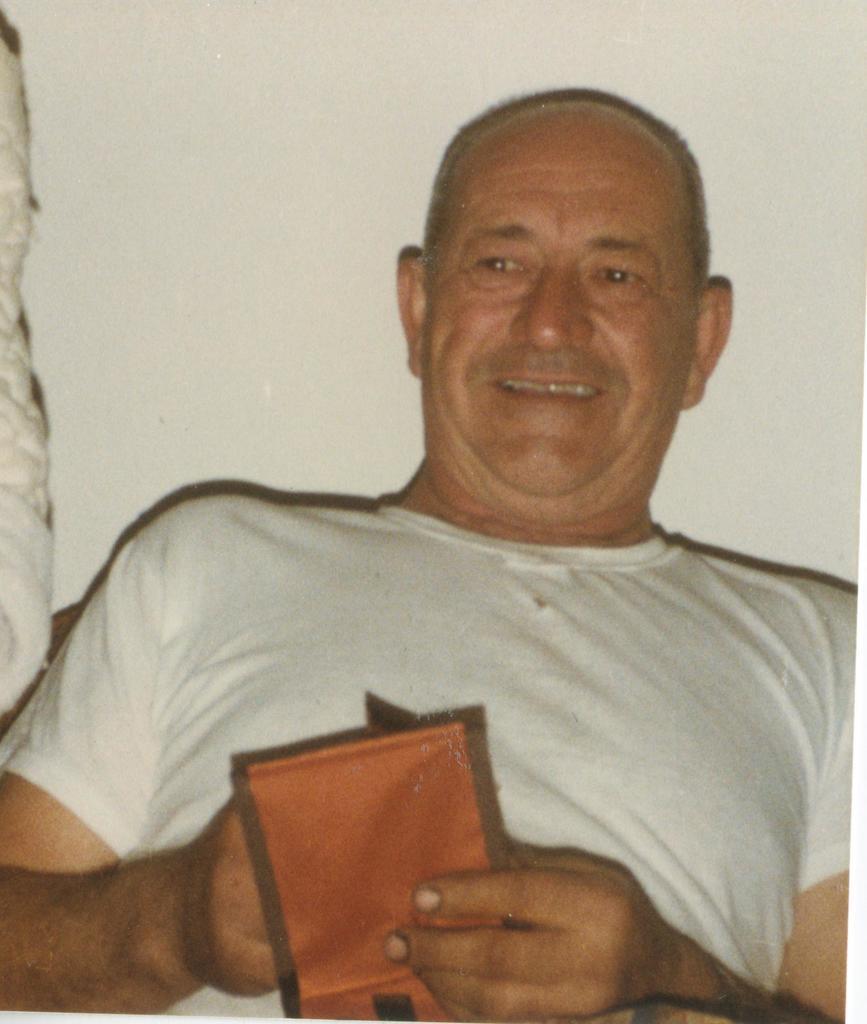How would you summarize this image in a sentence or two? In this picture there is a man holding a wallet, behind him we can see wall. 